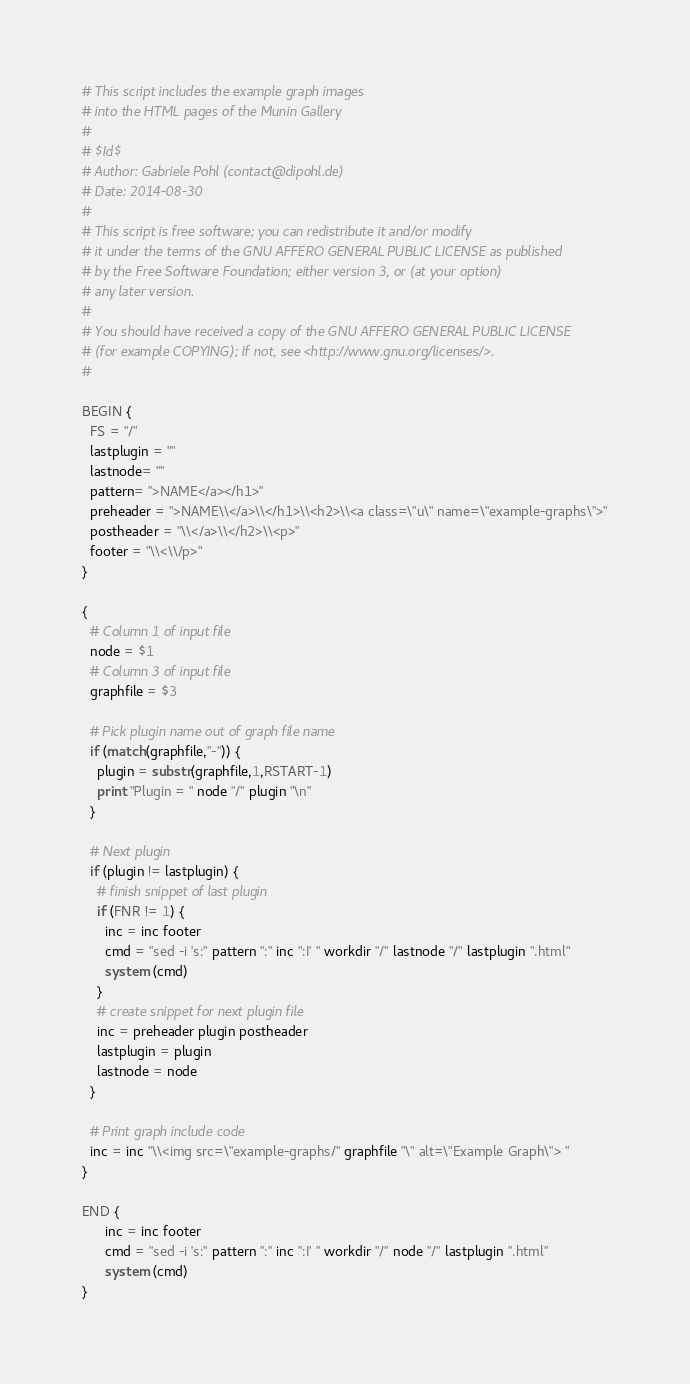<code> <loc_0><loc_0><loc_500><loc_500><_Awk_># This script includes the example graph images 
# into the HTML pages of the Munin Gallery
#
# $Id$
# Author: Gabriele Pohl (contact@dipohl.de)
# Date: 2014-08-30
# 
# This script is free software; you can redistribute it and/or modify
# it under the terms of the GNU AFFERO GENERAL PUBLIC LICENSE as published
# by the Free Software Foundation; either version 3, or (at your option)
# any later version.
#
# You should have received a copy of the GNU AFFERO GENERAL PUBLIC LICENSE
# (for example COPYING); If not, see <http://www.gnu.org/licenses/>.
#

BEGIN {
  FS = "/" 
  lastplugin = ""
  lastnode= ""
  pattern= ">NAME</a></h1>"
  preheader = ">NAME\\</a>\\</h1>\\<h2>\\<a class=\"u\" name=\"example-graphs\">"
  postheader = "\\</a>\\</h2>\\<p>"
  footer = "\\<\\/p>"
}

{
  # Column 1 of input file
  node = $1
  # Column 3 of input file
  graphfile = $3

  # Pick plugin name out of graph file name
  if (match(graphfile,"-")) {
    plugin = substr(graphfile,1,RSTART-1)
    print "Plugin = " node "/" plugin "\n"
  }

  # Next plugin
  if (plugin != lastplugin) {
    # finish snippet of last plugin
    if (FNR != 1) {
      inc = inc footer
      cmd = "sed -i 's:" pattern ":" inc ":I' " workdir "/" lastnode "/" lastplugin ".html"
      system (cmd)
    }
    # create snippet for next plugin file
    inc = preheader plugin postheader
    lastplugin = plugin
    lastnode = node
  }

  # Print graph include code
  inc = inc "\\<img src=\"example-graphs/" graphfile "\" alt=\"Example Graph\"> "
}

END { 
      inc = inc footer
      cmd = "sed -i 's:" pattern ":" inc ":I' " workdir "/" node "/" lastplugin ".html"
      system (cmd)
}
</code> 